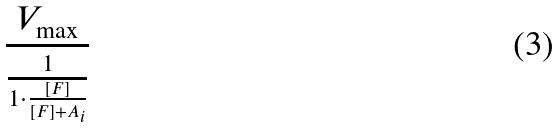Convert formula to latex. <formula><loc_0><loc_0><loc_500><loc_500>\frac { V _ { \max } } { \frac { 1 } { 1 \cdot \frac { [ F ] } { [ F ] + A _ { i } } } }</formula> 